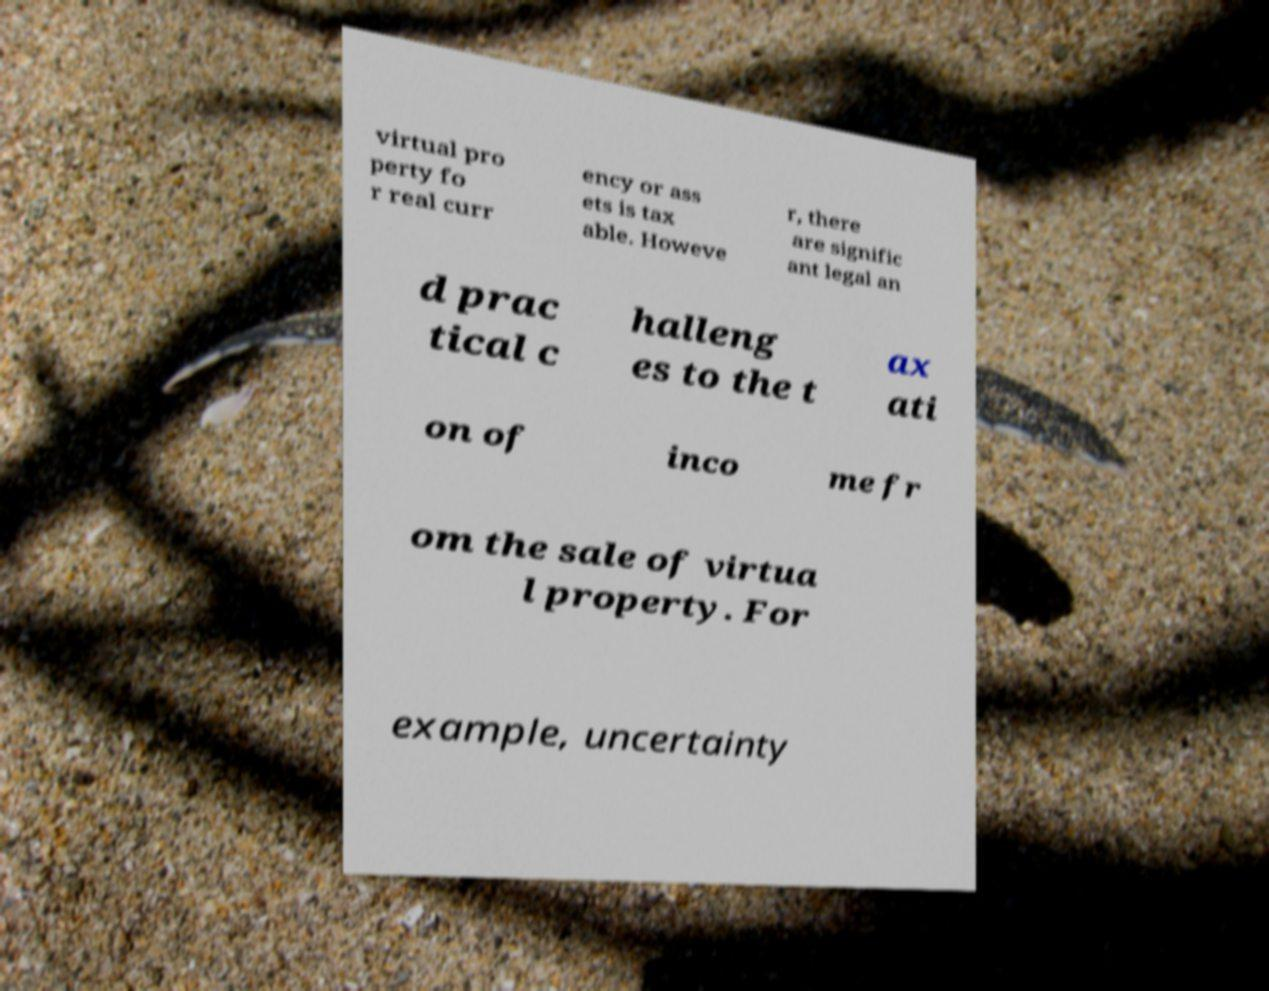Can you read and provide the text displayed in the image?This photo seems to have some interesting text. Can you extract and type it out for me? virtual pro perty fo r real curr ency or ass ets is tax able. Howeve r, there are signific ant legal an d prac tical c halleng es to the t ax ati on of inco me fr om the sale of virtua l property. For example, uncertainty 